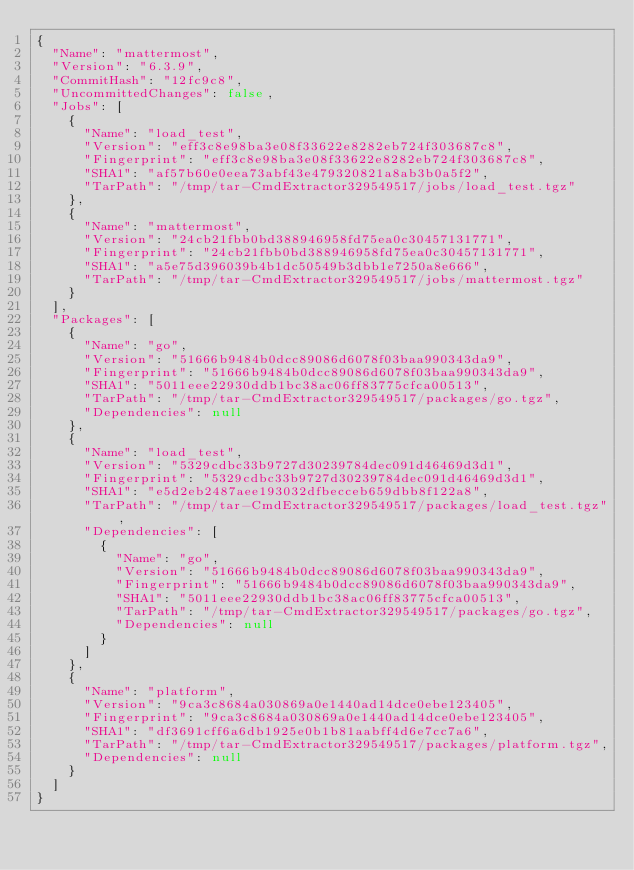Convert code to text. <code><loc_0><loc_0><loc_500><loc_500><_YAML_>{
  "Name": "mattermost",
  "Version": "6.3.9",
  "CommitHash": "12fc9c8",
  "UncommittedChanges": false,
  "Jobs": [
    {
      "Name": "load_test",
      "Version": "eff3c8e98ba3e08f33622e8282eb724f303687c8",
      "Fingerprint": "eff3c8e98ba3e08f33622e8282eb724f303687c8",
      "SHA1": "af57b60e0eea73abf43e479320821a8ab3b0a5f2",
      "TarPath": "/tmp/tar-CmdExtractor329549517/jobs/load_test.tgz"
    },
    {
      "Name": "mattermost",
      "Version": "24cb21fbb0bd388946958fd75ea0c30457131771",
      "Fingerprint": "24cb21fbb0bd388946958fd75ea0c30457131771",
      "SHA1": "a5e75d396039b4b1dc50549b3dbb1e7250a8e666",
      "TarPath": "/tmp/tar-CmdExtractor329549517/jobs/mattermost.tgz"
    }
  ],
  "Packages": [
    {
      "Name": "go",
      "Version": "51666b9484b0dcc89086d6078f03baa990343da9",
      "Fingerprint": "51666b9484b0dcc89086d6078f03baa990343da9",
      "SHA1": "5011eee22930ddb1bc38ac06ff83775cfca00513",
      "TarPath": "/tmp/tar-CmdExtractor329549517/packages/go.tgz",
      "Dependencies": null
    },
    {
      "Name": "load_test",
      "Version": "5329cdbc33b9727d30239784dec091d46469d3d1",
      "Fingerprint": "5329cdbc33b9727d30239784dec091d46469d3d1",
      "SHA1": "e5d2eb2487aee193032dfbecceb659dbb8f122a8",
      "TarPath": "/tmp/tar-CmdExtractor329549517/packages/load_test.tgz",
      "Dependencies": [
        {
          "Name": "go",
          "Version": "51666b9484b0dcc89086d6078f03baa990343da9",
          "Fingerprint": "51666b9484b0dcc89086d6078f03baa990343da9",
          "SHA1": "5011eee22930ddb1bc38ac06ff83775cfca00513",
          "TarPath": "/tmp/tar-CmdExtractor329549517/packages/go.tgz",
          "Dependencies": null
        }
      ]
    },
    {
      "Name": "platform",
      "Version": "9ca3c8684a030869a0e1440ad14dce0ebe123405",
      "Fingerprint": "9ca3c8684a030869a0e1440ad14dce0ebe123405",
      "SHA1": "df3691cff6a6db1925e0b1b81aabff4d6e7cc7a6",
      "TarPath": "/tmp/tar-CmdExtractor329549517/packages/platform.tgz",
      "Dependencies": null
    }
  ]
}</code> 